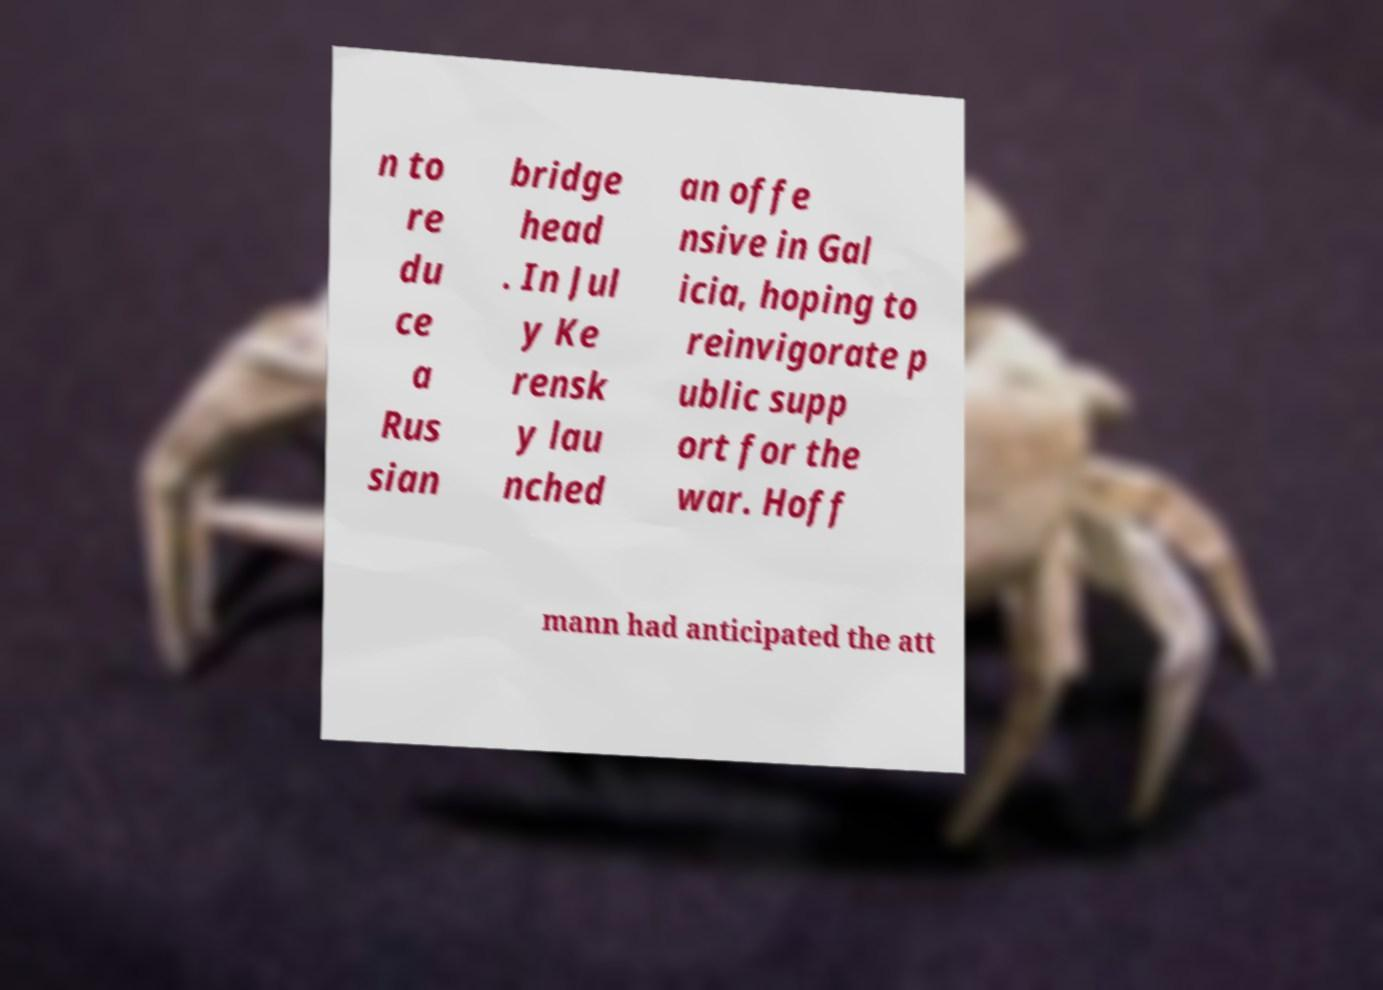Please read and relay the text visible in this image. What does it say? n to re du ce a Rus sian bridge head . In Jul y Ke rensk y lau nched an offe nsive in Gal icia, hoping to reinvigorate p ublic supp ort for the war. Hoff mann had anticipated the att 